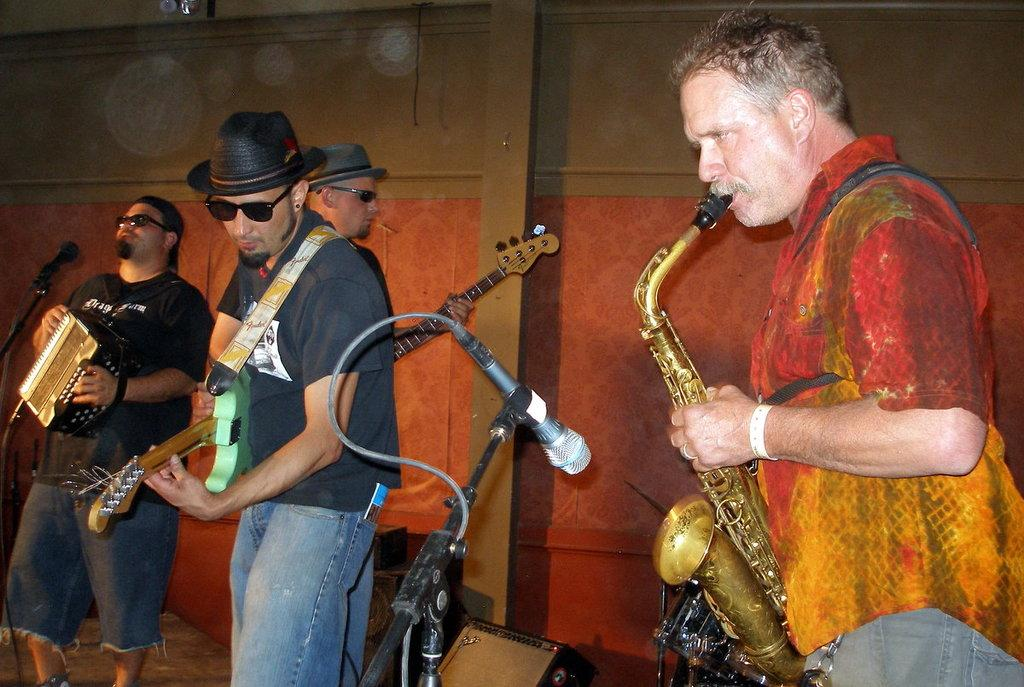What is happening in the image involving a group of people? There is a group of people in the image, and they are playing musical instruments. What are the people doing while playing the instruments? The people are standing while playing the musical instruments. What specific musical instruments can be seen in the image? The musical instruments include an accordion, a guitar, and a saxophone. What object is present in the image that might be used for amplifying sound? There is a microphone in the image. Can you describe the curtain behind the group of people in the image? There is no curtain visible in the image; it only shows a group of people playing musical instruments with a microphone. 